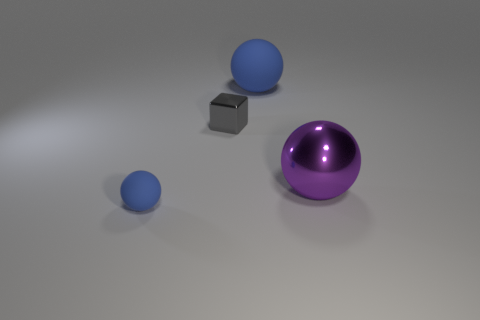Are the tiny block and the blue thing that is in front of the tiny shiny cube made of the same material?
Give a very brief answer. No. Is the number of purple objects to the left of the large purple metal sphere less than the number of blue matte spheres that are behind the small block?
Ensure brevity in your answer.  Yes. There is a small gray object that is left of the purple thing; what is it made of?
Make the answer very short. Metal. What color is the object that is both to the right of the cube and on the left side of the big purple object?
Offer a very short reply. Blue. How many other objects are there of the same color as the small metallic thing?
Your answer should be compact. 0. There is a matte thing that is in front of the large matte sphere; what is its color?
Give a very brief answer. Blue. Are there any other purple metal objects that have the same size as the purple shiny object?
Keep it short and to the point. No. There is a blue sphere that is the same size as the metallic cube; what is it made of?
Offer a terse response. Rubber. What number of things are either blue balls that are behind the small gray cube or blue rubber balls that are to the right of the tiny blue object?
Ensure brevity in your answer.  1. Are there any other blue matte objects of the same shape as the small rubber thing?
Ensure brevity in your answer.  Yes. 